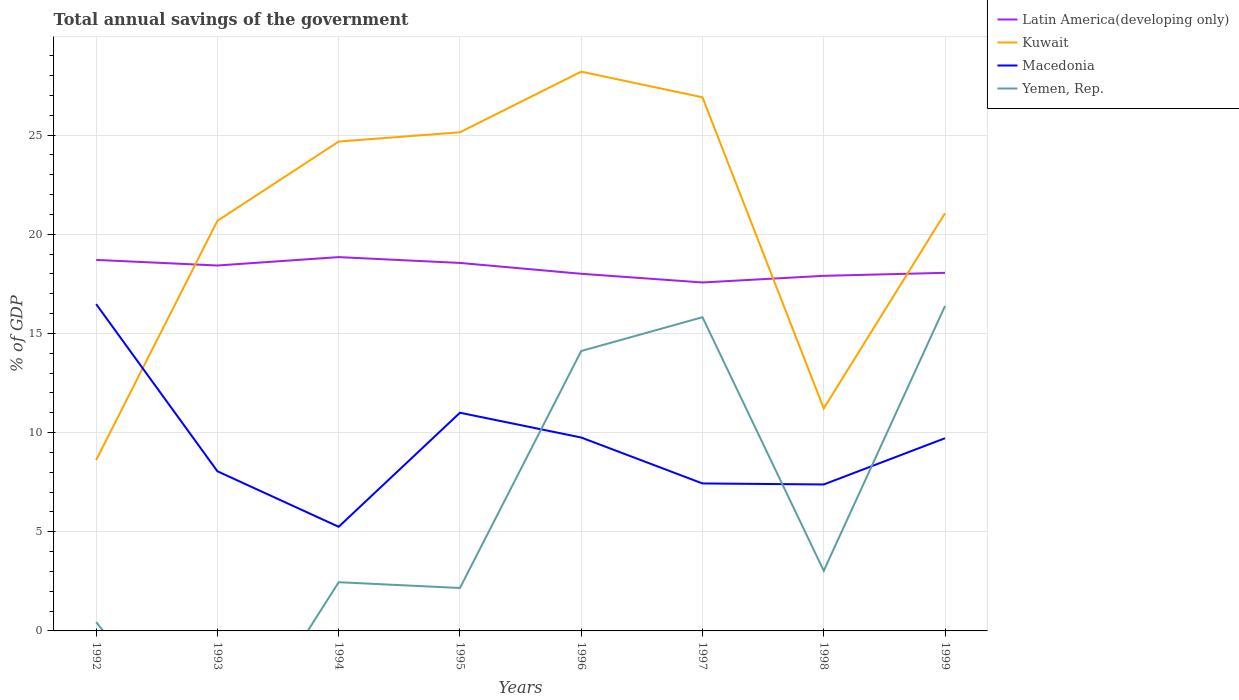Across all years, what is the maximum total annual savings of the government in Macedonia?
Offer a terse response. 5.25. What is the total total annual savings of the government in Kuwait in the graph?
Ensure brevity in your answer.  5.85. What is the difference between the highest and the second highest total annual savings of the government in Macedonia?
Give a very brief answer. 11.23. What is the difference between two consecutive major ticks on the Y-axis?
Offer a very short reply. 5. Does the graph contain any zero values?
Offer a terse response. Yes. How many legend labels are there?
Provide a short and direct response. 4. What is the title of the graph?
Provide a succinct answer. Total annual savings of the government. Does "Central African Republic" appear as one of the legend labels in the graph?
Give a very brief answer. No. What is the label or title of the X-axis?
Your answer should be very brief. Years. What is the label or title of the Y-axis?
Offer a very short reply. % of GDP. What is the % of GDP of Latin America(developing only) in 1992?
Ensure brevity in your answer.  18.71. What is the % of GDP in Kuwait in 1992?
Ensure brevity in your answer.  8.62. What is the % of GDP in Macedonia in 1992?
Offer a terse response. 16.48. What is the % of GDP of Yemen, Rep. in 1992?
Offer a very short reply. 0.45. What is the % of GDP of Latin America(developing only) in 1993?
Offer a terse response. 18.42. What is the % of GDP in Kuwait in 1993?
Provide a succinct answer. 20.68. What is the % of GDP of Macedonia in 1993?
Offer a very short reply. 8.05. What is the % of GDP of Yemen, Rep. in 1993?
Provide a succinct answer. 0. What is the % of GDP of Latin America(developing only) in 1994?
Ensure brevity in your answer.  18.85. What is the % of GDP in Kuwait in 1994?
Your answer should be compact. 24.67. What is the % of GDP in Macedonia in 1994?
Make the answer very short. 5.25. What is the % of GDP of Yemen, Rep. in 1994?
Your response must be concise. 2.46. What is the % of GDP in Latin America(developing only) in 1995?
Your response must be concise. 18.55. What is the % of GDP in Kuwait in 1995?
Make the answer very short. 25.14. What is the % of GDP in Macedonia in 1995?
Offer a terse response. 11. What is the % of GDP in Yemen, Rep. in 1995?
Keep it short and to the point. 2.16. What is the % of GDP of Latin America(developing only) in 1996?
Offer a very short reply. 18.01. What is the % of GDP of Kuwait in 1996?
Give a very brief answer. 28.2. What is the % of GDP in Macedonia in 1996?
Ensure brevity in your answer.  9.75. What is the % of GDP in Yemen, Rep. in 1996?
Keep it short and to the point. 14.11. What is the % of GDP in Latin America(developing only) in 1997?
Give a very brief answer. 17.57. What is the % of GDP in Kuwait in 1997?
Provide a short and direct response. 26.9. What is the % of GDP in Macedonia in 1997?
Provide a succinct answer. 7.44. What is the % of GDP of Yemen, Rep. in 1997?
Offer a terse response. 15.82. What is the % of GDP in Latin America(developing only) in 1998?
Offer a terse response. 17.9. What is the % of GDP of Kuwait in 1998?
Your answer should be very brief. 11.22. What is the % of GDP in Macedonia in 1998?
Keep it short and to the point. 7.38. What is the % of GDP of Yemen, Rep. in 1998?
Keep it short and to the point. 3.03. What is the % of GDP of Latin America(developing only) in 1999?
Offer a very short reply. 18.06. What is the % of GDP of Kuwait in 1999?
Make the answer very short. 21.06. What is the % of GDP of Macedonia in 1999?
Your response must be concise. 9.72. What is the % of GDP of Yemen, Rep. in 1999?
Provide a short and direct response. 16.38. Across all years, what is the maximum % of GDP in Latin America(developing only)?
Provide a succinct answer. 18.85. Across all years, what is the maximum % of GDP in Kuwait?
Your response must be concise. 28.2. Across all years, what is the maximum % of GDP in Macedonia?
Keep it short and to the point. 16.48. Across all years, what is the maximum % of GDP of Yemen, Rep.?
Provide a short and direct response. 16.38. Across all years, what is the minimum % of GDP of Latin America(developing only)?
Ensure brevity in your answer.  17.57. Across all years, what is the minimum % of GDP of Kuwait?
Keep it short and to the point. 8.62. Across all years, what is the minimum % of GDP in Macedonia?
Provide a succinct answer. 5.25. What is the total % of GDP of Latin America(developing only) in the graph?
Make the answer very short. 146.07. What is the total % of GDP in Kuwait in the graph?
Offer a very short reply. 166.49. What is the total % of GDP of Macedonia in the graph?
Offer a terse response. 75.07. What is the total % of GDP of Yemen, Rep. in the graph?
Offer a terse response. 54.41. What is the difference between the % of GDP of Latin America(developing only) in 1992 and that in 1993?
Offer a very short reply. 0.28. What is the difference between the % of GDP in Kuwait in 1992 and that in 1993?
Make the answer very short. -12.06. What is the difference between the % of GDP in Macedonia in 1992 and that in 1993?
Your answer should be very brief. 8.43. What is the difference between the % of GDP of Latin America(developing only) in 1992 and that in 1994?
Offer a terse response. -0.14. What is the difference between the % of GDP in Kuwait in 1992 and that in 1994?
Provide a succinct answer. -16.06. What is the difference between the % of GDP in Macedonia in 1992 and that in 1994?
Give a very brief answer. 11.23. What is the difference between the % of GDP in Yemen, Rep. in 1992 and that in 1994?
Your answer should be compact. -2.01. What is the difference between the % of GDP of Latin America(developing only) in 1992 and that in 1995?
Your response must be concise. 0.15. What is the difference between the % of GDP in Kuwait in 1992 and that in 1995?
Ensure brevity in your answer.  -16.53. What is the difference between the % of GDP in Macedonia in 1992 and that in 1995?
Keep it short and to the point. 5.48. What is the difference between the % of GDP in Yemen, Rep. in 1992 and that in 1995?
Your response must be concise. -1.72. What is the difference between the % of GDP in Latin America(developing only) in 1992 and that in 1996?
Keep it short and to the point. 0.7. What is the difference between the % of GDP in Kuwait in 1992 and that in 1996?
Keep it short and to the point. -19.58. What is the difference between the % of GDP in Macedonia in 1992 and that in 1996?
Your answer should be very brief. 6.73. What is the difference between the % of GDP of Yemen, Rep. in 1992 and that in 1996?
Ensure brevity in your answer.  -13.67. What is the difference between the % of GDP in Latin America(developing only) in 1992 and that in 1997?
Your answer should be compact. 1.14. What is the difference between the % of GDP in Kuwait in 1992 and that in 1997?
Offer a terse response. -18.29. What is the difference between the % of GDP of Macedonia in 1992 and that in 1997?
Provide a short and direct response. 9.04. What is the difference between the % of GDP in Yemen, Rep. in 1992 and that in 1997?
Provide a succinct answer. -15.37. What is the difference between the % of GDP of Latin America(developing only) in 1992 and that in 1998?
Your answer should be very brief. 0.8. What is the difference between the % of GDP in Kuwait in 1992 and that in 1998?
Your response must be concise. -2.6. What is the difference between the % of GDP of Macedonia in 1992 and that in 1998?
Keep it short and to the point. 9.09. What is the difference between the % of GDP of Yemen, Rep. in 1992 and that in 1998?
Make the answer very short. -2.58. What is the difference between the % of GDP in Latin America(developing only) in 1992 and that in 1999?
Offer a very short reply. 0.65. What is the difference between the % of GDP in Kuwait in 1992 and that in 1999?
Make the answer very short. -12.44. What is the difference between the % of GDP in Macedonia in 1992 and that in 1999?
Your response must be concise. 6.76. What is the difference between the % of GDP of Yemen, Rep. in 1992 and that in 1999?
Keep it short and to the point. -15.93. What is the difference between the % of GDP of Latin America(developing only) in 1993 and that in 1994?
Give a very brief answer. -0.42. What is the difference between the % of GDP of Kuwait in 1993 and that in 1994?
Make the answer very short. -4. What is the difference between the % of GDP in Macedonia in 1993 and that in 1994?
Provide a succinct answer. 2.8. What is the difference between the % of GDP in Latin America(developing only) in 1993 and that in 1995?
Provide a short and direct response. -0.13. What is the difference between the % of GDP in Kuwait in 1993 and that in 1995?
Your response must be concise. -4.46. What is the difference between the % of GDP in Macedonia in 1993 and that in 1995?
Provide a short and direct response. -2.95. What is the difference between the % of GDP in Latin America(developing only) in 1993 and that in 1996?
Keep it short and to the point. 0.42. What is the difference between the % of GDP of Kuwait in 1993 and that in 1996?
Provide a short and direct response. -7.52. What is the difference between the % of GDP in Macedonia in 1993 and that in 1996?
Your answer should be very brief. -1.7. What is the difference between the % of GDP in Latin America(developing only) in 1993 and that in 1997?
Provide a succinct answer. 0.86. What is the difference between the % of GDP in Kuwait in 1993 and that in 1997?
Provide a succinct answer. -6.23. What is the difference between the % of GDP in Macedonia in 1993 and that in 1997?
Your answer should be compact. 0.61. What is the difference between the % of GDP of Latin America(developing only) in 1993 and that in 1998?
Provide a short and direct response. 0.52. What is the difference between the % of GDP in Kuwait in 1993 and that in 1998?
Your answer should be compact. 9.46. What is the difference between the % of GDP of Macedonia in 1993 and that in 1998?
Keep it short and to the point. 0.67. What is the difference between the % of GDP in Latin America(developing only) in 1993 and that in 1999?
Keep it short and to the point. 0.37. What is the difference between the % of GDP of Kuwait in 1993 and that in 1999?
Make the answer very short. -0.38. What is the difference between the % of GDP in Macedonia in 1993 and that in 1999?
Offer a very short reply. -1.67. What is the difference between the % of GDP of Latin America(developing only) in 1994 and that in 1995?
Offer a very short reply. 0.29. What is the difference between the % of GDP in Kuwait in 1994 and that in 1995?
Keep it short and to the point. -0.47. What is the difference between the % of GDP in Macedonia in 1994 and that in 1995?
Keep it short and to the point. -5.75. What is the difference between the % of GDP of Yemen, Rep. in 1994 and that in 1995?
Ensure brevity in your answer.  0.29. What is the difference between the % of GDP of Latin America(developing only) in 1994 and that in 1996?
Your answer should be compact. 0.84. What is the difference between the % of GDP of Kuwait in 1994 and that in 1996?
Make the answer very short. -3.52. What is the difference between the % of GDP in Macedonia in 1994 and that in 1996?
Offer a terse response. -4.5. What is the difference between the % of GDP in Yemen, Rep. in 1994 and that in 1996?
Your answer should be very brief. -11.66. What is the difference between the % of GDP in Latin America(developing only) in 1994 and that in 1997?
Your response must be concise. 1.28. What is the difference between the % of GDP of Kuwait in 1994 and that in 1997?
Your response must be concise. -2.23. What is the difference between the % of GDP in Macedonia in 1994 and that in 1997?
Keep it short and to the point. -2.19. What is the difference between the % of GDP in Yemen, Rep. in 1994 and that in 1997?
Provide a succinct answer. -13.36. What is the difference between the % of GDP in Latin America(developing only) in 1994 and that in 1998?
Offer a terse response. 0.94. What is the difference between the % of GDP of Kuwait in 1994 and that in 1998?
Your answer should be very brief. 13.46. What is the difference between the % of GDP of Macedonia in 1994 and that in 1998?
Provide a succinct answer. -2.13. What is the difference between the % of GDP in Yemen, Rep. in 1994 and that in 1998?
Your answer should be compact. -0.58. What is the difference between the % of GDP of Latin America(developing only) in 1994 and that in 1999?
Provide a short and direct response. 0.79. What is the difference between the % of GDP of Kuwait in 1994 and that in 1999?
Give a very brief answer. 3.61. What is the difference between the % of GDP in Macedonia in 1994 and that in 1999?
Keep it short and to the point. -4.47. What is the difference between the % of GDP in Yemen, Rep. in 1994 and that in 1999?
Provide a succinct answer. -13.93. What is the difference between the % of GDP of Latin America(developing only) in 1995 and that in 1996?
Your response must be concise. 0.55. What is the difference between the % of GDP of Kuwait in 1995 and that in 1996?
Keep it short and to the point. -3.06. What is the difference between the % of GDP in Macedonia in 1995 and that in 1996?
Make the answer very short. 1.25. What is the difference between the % of GDP in Yemen, Rep. in 1995 and that in 1996?
Give a very brief answer. -11.95. What is the difference between the % of GDP of Latin America(developing only) in 1995 and that in 1997?
Provide a succinct answer. 0.98. What is the difference between the % of GDP in Kuwait in 1995 and that in 1997?
Give a very brief answer. -1.76. What is the difference between the % of GDP of Macedonia in 1995 and that in 1997?
Keep it short and to the point. 3.57. What is the difference between the % of GDP of Yemen, Rep. in 1995 and that in 1997?
Give a very brief answer. -13.65. What is the difference between the % of GDP of Latin America(developing only) in 1995 and that in 1998?
Ensure brevity in your answer.  0.65. What is the difference between the % of GDP in Kuwait in 1995 and that in 1998?
Your answer should be compact. 13.92. What is the difference between the % of GDP in Macedonia in 1995 and that in 1998?
Provide a short and direct response. 3.62. What is the difference between the % of GDP of Yemen, Rep. in 1995 and that in 1998?
Keep it short and to the point. -0.87. What is the difference between the % of GDP in Latin America(developing only) in 1995 and that in 1999?
Offer a terse response. 0.5. What is the difference between the % of GDP of Kuwait in 1995 and that in 1999?
Give a very brief answer. 4.08. What is the difference between the % of GDP of Macedonia in 1995 and that in 1999?
Provide a succinct answer. 1.28. What is the difference between the % of GDP in Yemen, Rep. in 1995 and that in 1999?
Provide a succinct answer. -14.22. What is the difference between the % of GDP in Latin America(developing only) in 1996 and that in 1997?
Provide a short and direct response. 0.44. What is the difference between the % of GDP of Kuwait in 1996 and that in 1997?
Offer a terse response. 1.29. What is the difference between the % of GDP of Macedonia in 1996 and that in 1997?
Keep it short and to the point. 2.32. What is the difference between the % of GDP in Yemen, Rep. in 1996 and that in 1997?
Provide a short and direct response. -1.7. What is the difference between the % of GDP in Latin America(developing only) in 1996 and that in 1998?
Make the answer very short. 0.1. What is the difference between the % of GDP of Kuwait in 1996 and that in 1998?
Offer a very short reply. 16.98. What is the difference between the % of GDP of Macedonia in 1996 and that in 1998?
Your response must be concise. 2.37. What is the difference between the % of GDP of Yemen, Rep. in 1996 and that in 1998?
Your answer should be compact. 11.08. What is the difference between the % of GDP in Latin America(developing only) in 1996 and that in 1999?
Offer a very short reply. -0.05. What is the difference between the % of GDP in Kuwait in 1996 and that in 1999?
Offer a terse response. 7.14. What is the difference between the % of GDP in Macedonia in 1996 and that in 1999?
Your answer should be compact. 0.04. What is the difference between the % of GDP in Yemen, Rep. in 1996 and that in 1999?
Offer a very short reply. -2.27. What is the difference between the % of GDP in Latin America(developing only) in 1997 and that in 1998?
Provide a succinct answer. -0.33. What is the difference between the % of GDP of Kuwait in 1997 and that in 1998?
Keep it short and to the point. 15.69. What is the difference between the % of GDP of Macedonia in 1997 and that in 1998?
Keep it short and to the point. 0.05. What is the difference between the % of GDP in Yemen, Rep. in 1997 and that in 1998?
Offer a very short reply. 12.79. What is the difference between the % of GDP in Latin America(developing only) in 1997 and that in 1999?
Your response must be concise. -0.49. What is the difference between the % of GDP in Kuwait in 1997 and that in 1999?
Your answer should be compact. 5.84. What is the difference between the % of GDP in Macedonia in 1997 and that in 1999?
Your answer should be compact. -2.28. What is the difference between the % of GDP in Yemen, Rep. in 1997 and that in 1999?
Your answer should be compact. -0.56. What is the difference between the % of GDP in Latin America(developing only) in 1998 and that in 1999?
Ensure brevity in your answer.  -0.15. What is the difference between the % of GDP in Kuwait in 1998 and that in 1999?
Ensure brevity in your answer.  -9.84. What is the difference between the % of GDP of Macedonia in 1998 and that in 1999?
Give a very brief answer. -2.33. What is the difference between the % of GDP of Yemen, Rep. in 1998 and that in 1999?
Offer a terse response. -13.35. What is the difference between the % of GDP in Latin America(developing only) in 1992 and the % of GDP in Kuwait in 1993?
Provide a short and direct response. -1.97. What is the difference between the % of GDP in Latin America(developing only) in 1992 and the % of GDP in Macedonia in 1993?
Your answer should be very brief. 10.66. What is the difference between the % of GDP in Kuwait in 1992 and the % of GDP in Macedonia in 1993?
Provide a short and direct response. 0.57. What is the difference between the % of GDP of Latin America(developing only) in 1992 and the % of GDP of Kuwait in 1994?
Provide a succinct answer. -5.97. What is the difference between the % of GDP in Latin America(developing only) in 1992 and the % of GDP in Macedonia in 1994?
Your answer should be compact. 13.46. What is the difference between the % of GDP of Latin America(developing only) in 1992 and the % of GDP of Yemen, Rep. in 1994?
Your answer should be very brief. 16.25. What is the difference between the % of GDP in Kuwait in 1992 and the % of GDP in Macedonia in 1994?
Your answer should be very brief. 3.37. What is the difference between the % of GDP in Kuwait in 1992 and the % of GDP in Yemen, Rep. in 1994?
Offer a very short reply. 6.16. What is the difference between the % of GDP in Macedonia in 1992 and the % of GDP in Yemen, Rep. in 1994?
Ensure brevity in your answer.  14.02. What is the difference between the % of GDP of Latin America(developing only) in 1992 and the % of GDP of Kuwait in 1995?
Ensure brevity in your answer.  -6.44. What is the difference between the % of GDP in Latin America(developing only) in 1992 and the % of GDP in Macedonia in 1995?
Offer a very short reply. 7.71. What is the difference between the % of GDP of Latin America(developing only) in 1992 and the % of GDP of Yemen, Rep. in 1995?
Make the answer very short. 16.54. What is the difference between the % of GDP in Kuwait in 1992 and the % of GDP in Macedonia in 1995?
Make the answer very short. -2.39. What is the difference between the % of GDP of Kuwait in 1992 and the % of GDP of Yemen, Rep. in 1995?
Give a very brief answer. 6.45. What is the difference between the % of GDP in Macedonia in 1992 and the % of GDP in Yemen, Rep. in 1995?
Offer a very short reply. 14.31. What is the difference between the % of GDP of Latin America(developing only) in 1992 and the % of GDP of Kuwait in 1996?
Your response must be concise. -9.49. What is the difference between the % of GDP of Latin America(developing only) in 1992 and the % of GDP of Macedonia in 1996?
Your answer should be very brief. 8.96. What is the difference between the % of GDP in Latin America(developing only) in 1992 and the % of GDP in Yemen, Rep. in 1996?
Keep it short and to the point. 4.59. What is the difference between the % of GDP in Kuwait in 1992 and the % of GDP in Macedonia in 1996?
Offer a terse response. -1.14. What is the difference between the % of GDP in Kuwait in 1992 and the % of GDP in Yemen, Rep. in 1996?
Your answer should be very brief. -5.5. What is the difference between the % of GDP in Macedonia in 1992 and the % of GDP in Yemen, Rep. in 1996?
Your answer should be compact. 2.37. What is the difference between the % of GDP of Latin America(developing only) in 1992 and the % of GDP of Kuwait in 1997?
Your answer should be very brief. -8.2. What is the difference between the % of GDP in Latin America(developing only) in 1992 and the % of GDP in Macedonia in 1997?
Offer a very short reply. 11.27. What is the difference between the % of GDP in Latin America(developing only) in 1992 and the % of GDP in Yemen, Rep. in 1997?
Make the answer very short. 2.89. What is the difference between the % of GDP of Kuwait in 1992 and the % of GDP of Macedonia in 1997?
Offer a terse response. 1.18. What is the difference between the % of GDP of Kuwait in 1992 and the % of GDP of Yemen, Rep. in 1997?
Ensure brevity in your answer.  -7.2. What is the difference between the % of GDP of Macedonia in 1992 and the % of GDP of Yemen, Rep. in 1997?
Your answer should be very brief. 0.66. What is the difference between the % of GDP of Latin America(developing only) in 1992 and the % of GDP of Kuwait in 1998?
Make the answer very short. 7.49. What is the difference between the % of GDP in Latin America(developing only) in 1992 and the % of GDP in Macedonia in 1998?
Your answer should be compact. 11.32. What is the difference between the % of GDP of Latin America(developing only) in 1992 and the % of GDP of Yemen, Rep. in 1998?
Give a very brief answer. 15.68. What is the difference between the % of GDP of Kuwait in 1992 and the % of GDP of Macedonia in 1998?
Provide a succinct answer. 1.23. What is the difference between the % of GDP in Kuwait in 1992 and the % of GDP in Yemen, Rep. in 1998?
Ensure brevity in your answer.  5.58. What is the difference between the % of GDP in Macedonia in 1992 and the % of GDP in Yemen, Rep. in 1998?
Make the answer very short. 13.45. What is the difference between the % of GDP of Latin America(developing only) in 1992 and the % of GDP of Kuwait in 1999?
Your answer should be compact. -2.35. What is the difference between the % of GDP of Latin America(developing only) in 1992 and the % of GDP of Macedonia in 1999?
Keep it short and to the point. 8.99. What is the difference between the % of GDP in Latin America(developing only) in 1992 and the % of GDP in Yemen, Rep. in 1999?
Keep it short and to the point. 2.33. What is the difference between the % of GDP in Kuwait in 1992 and the % of GDP in Macedonia in 1999?
Give a very brief answer. -1.1. What is the difference between the % of GDP in Kuwait in 1992 and the % of GDP in Yemen, Rep. in 1999?
Offer a terse response. -7.77. What is the difference between the % of GDP in Macedonia in 1992 and the % of GDP in Yemen, Rep. in 1999?
Ensure brevity in your answer.  0.1. What is the difference between the % of GDP in Latin America(developing only) in 1993 and the % of GDP in Kuwait in 1994?
Offer a very short reply. -6.25. What is the difference between the % of GDP of Latin America(developing only) in 1993 and the % of GDP of Macedonia in 1994?
Provide a short and direct response. 13.17. What is the difference between the % of GDP in Latin America(developing only) in 1993 and the % of GDP in Yemen, Rep. in 1994?
Your response must be concise. 15.97. What is the difference between the % of GDP of Kuwait in 1993 and the % of GDP of Macedonia in 1994?
Your answer should be very brief. 15.43. What is the difference between the % of GDP in Kuwait in 1993 and the % of GDP in Yemen, Rep. in 1994?
Provide a short and direct response. 18.22. What is the difference between the % of GDP in Macedonia in 1993 and the % of GDP in Yemen, Rep. in 1994?
Give a very brief answer. 5.59. What is the difference between the % of GDP of Latin America(developing only) in 1993 and the % of GDP of Kuwait in 1995?
Keep it short and to the point. -6.72. What is the difference between the % of GDP of Latin America(developing only) in 1993 and the % of GDP of Macedonia in 1995?
Make the answer very short. 7.42. What is the difference between the % of GDP in Latin America(developing only) in 1993 and the % of GDP in Yemen, Rep. in 1995?
Offer a terse response. 16.26. What is the difference between the % of GDP of Kuwait in 1993 and the % of GDP of Macedonia in 1995?
Give a very brief answer. 9.68. What is the difference between the % of GDP of Kuwait in 1993 and the % of GDP of Yemen, Rep. in 1995?
Offer a very short reply. 18.51. What is the difference between the % of GDP in Macedonia in 1993 and the % of GDP in Yemen, Rep. in 1995?
Offer a very short reply. 5.88. What is the difference between the % of GDP of Latin America(developing only) in 1993 and the % of GDP of Kuwait in 1996?
Your response must be concise. -9.77. What is the difference between the % of GDP in Latin America(developing only) in 1993 and the % of GDP in Macedonia in 1996?
Offer a terse response. 8.67. What is the difference between the % of GDP in Latin America(developing only) in 1993 and the % of GDP in Yemen, Rep. in 1996?
Ensure brevity in your answer.  4.31. What is the difference between the % of GDP of Kuwait in 1993 and the % of GDP of Macedonia in 1996?
Give a very brief answer. 10.93. What is the difference between the % of GDP in Kuwait in 1993 and the % of GDP in Yemen, Rep. in 1996?
Provide a succinct answer. 6.56. What is the difference between the % of GDP of Macedonia in 1993 and the % of GDP of Yemen, Rep. in 1996?
Your answer should be very brief. -6.06. What is the difference between the % of GDP of Latin America(developing only) in 1993 and the % of GDP of Kuwait in 1997?
Ensure brevity in your answer.  -8.48. What is the difference between the % of GDP in Latin America(developing only) in 1993 and the % of GDP in Macedonia in 1997?
Keep it short and to the point. 10.99. What is the difference between the % of GDP in Latin America(developing only) in 1993 and the % of GDP in Yemen, Rep. in 1997?
Your answer should be compact. 2.61. What is the difference between the % of GDP of Kuwait in 1993 and the % of GDP of Macedonia in 1997?
Your answer should be compact. 13.24. What is the difference between the % of GDP of Kuwait in 1993 and the % of GDP of Yemen, Rep. in 1997?
Offer a terse response. 4.86. What is the difference between the % of GDP in Macedonia in 1993 and the % of GDP in Yemen, Rep. in 1997?
Ensure brevity in your answer.  -7.77. What is the difference between the % of GDP in Latin America(developing only) in 1993 and the % of GDP in Kuwait in 1998?
Your answer should be compact. 7.21. What is the difference between the % of GDP in Latin America(developing only) in 1993 and the % of GDP in Macedonia in 1998?
Ensure brevity in your answer.  11.04. What is the difference between the % of GDP of Latin America(developing only) in 1993 and the % of GDP of Yemen, Rep. in 1998?
Your answer should be very brief. 15.39. What is the difference between the % of GDP of Kuwait in 1993 and the % of GDP of Macedonia in 1998?
Keep it short and to the point. 13.29. What is the difference between the % of GDP of Kuwait in 1993 and the % of GDP of Yemen, Rep. in 1998?
Provide a succinct answer. 17.65. What is the difference between the % of GDP of Macedonia in 1993 and the % of GDP of Yemen, Rep. in 1998?
Give a very brief answer. 5.02. What is the difference between the % of GDP in Latin America(developing only) in 1993 and the % of GDP in Kuwait in 1999?
Your answer should be compact. -2.64. What is the difference between the % of GDP in Latin America(developing only) in 1993 and the % of GDP in Macedonia in 1999?
Offer a terse response. 8.71. What is the difference between the % of GDP in Latin America(developing only) in 1993 and the % of GDP in Yemen, Rep. in 1999?
Ensure brevity in your answer.  2.04. What is the difference between the % of GDP in Kuwait in 1993 and the % of GDP in Macedonia in 1999?
Make the answer very short. 10.96. What is the difference between the % of GDP of Kuwait in 1993 and the % of GDP of Yemen, Rep. in 1999?
Make the answer very short. 4.3. What is the difference between the % of GDP in Macedonia in 1993 and the % of GDP in Yemen, Rep. in 1999?
Give a very brief answer. -8.33. What is the difference between the % of GDP of Latin America(developing only) in 1994 and the % of GDP of Kuwait in 1995?
Keep it short and to the point. -6.29. What is the difference between the % of GDP in Latin America(developing only) in 1994 and the % of GDP in Macedonia in 1995?
Provide a short and direct response. 7.85. What is the difference between the % of GDP of Latin America(developing only) in 1994 and the % of GDP of Yemen, Rep. in 1995?
Your answer should be very brief. 16.68. What is the difference between the % of GDP of Kuwait in 1994 and the % of GDP of Macedonia in 1995?
Make the answer very short. 13.67. What is the difference between the % of GDP in Kuwait in 1994 and the % of GDP in Yemen, Rep. in 1995?
Your response must be concise. 22.51. What is the difference between the % of GDP in Macedonia in 1994 and the % of GDP in Yemen, Rep. in 1995?
Make the answer very short. 3.09. What is the difference between the % of GDP in Latin America(developing only) in 1994 and the % of GDP in Kuwait in 1996?
Offer a very short reply. -9.35. What is the difference between the % of GDP of Latin America(developing only) in 1994 and the % of GDP of Macedonia in 1996?
Offer a terse response. 9.1. What is the difference between the % of GDP of Latin America(developing only) in 1994 and the % of GDP of Yemen, Rep. in 1996?
Offer a terse response. 4.73. What is the difference between the % of GDP in Kuwait in 1994 and the % of GDP in Macedonia in 1996?
Ensure brevity in your answer.  14.92. What is the difference between the % of GDP of Kuwait in 1994 and the % of GDP of Yemen, Rep. in 1996?
Your response must be concise. 10.56. What is the difference between the % of GDP of Macedonia in 1994 and the % of GDP of Yemen, Rep. in 1996?
Ensure brevity in your answer.  -8.86. What is the difference between the % of GDP in Latin America(developing only) in 1994 and the % of GDP in Kuwait in 1997?
Keep it short and to the point. -8.06. What is the difference between the % of GDP in Latin America(developing only) in 1994 and the % of GDP in Macedonia in 1997?
Make the answer very short. 11.41. What is the difference between the % of GDP of Latin America(developing only) in 1994 and the % of GDP of Yemen, Rep. in 1997?
Provide a short and direct response. 3.03. What is the difference between the % of GDP of Kuwait in 1994 and the % of GDP of Macedonia in 1997?
Your response must be concise. 17.24. What is the difference between the % of GDP in Kuwait in 1994 and the % of GDP in Yemen, Rep. in 1997?
Make the answer very short. 8.86. What is the difference between the % of GDP of Macedonia in 1994 and the % of GDP of Yemen, Rep. in 1997?
Your response must be concise. -10.57. What is the difference between the % of GDP of Latin America(developing only) in 1994 and the % of GDP of Kuwait in 1998?
Make the answer very short. 7.63. What is the difference between the % of GDP in Latin America(developing only) in 1994 and the % of GDP in Macedonia in 1998?
Give a very brief answer. 11.46. What is the difference between the % of GDP in Latin America(developing only) in 1994 and the % of GDP in Yemen, Rep. in 1998?
Provide a succinct answer. 15.82. What is the difference between the % of GDP in Kuwait in 1994 and the % of GDP in Macedonia in 1998?
Keep it short and to the point. 17.29. What is the difference between the % of GDP in Kuwait in 1994 and the % of GDP in Yemen, Rep. in 1998?
Offer a terse response. 21.64. What is the difference between the % of GDP in Macedonia in 1994 and the % of GDP in Yemen, Rep. in 1998?
Keep it short and to the point. 2.22. What is the difference between the % of GDP of Latin America(developing only) in 1994 and the % of GDP of Kuwait in 1999?
Keep it short and to the point. -2.21. What is the difference between the % of GDP of Latin America(developing only) in 1994 and the % of GDP of Macedonia in 1999?
Keep it short and to the point. 9.13. What is the difference between the % of GDP of Latin America(developing only) in 1994 and the % of GDP of Yemen, Rep. in 1999?
Offer a terse response. 2.47. What is the difference between the % of GDP in Kuwait in 1994 and the % of GDP in Macedonia in 1999?
Your response must be concise. 14.96. What is the difference between the % of GDP in Kuwait in 1994 and the % of GDP in Yemen, Rep. in 1999?
Make the answer very short. 8.29. What is the difference between the % of GDP of Macedonia in 1994 and the % of GDP of Yemen, Rep. in 1999?
Offer a very short reply. -11.13. What is the difference between the % of GDP of Latin America(developing only) in 1995 and the % of GDP of Kuwait in 1996?
Provide a succinct answer. -9.65. What is the difference between the % of GDP of Latin America(developing only) in 1995 and the % of GDP of Macedonia in 1996?
Your answer should be very brief. 8.8. What is the difference between the % of GDP of Latin America(developing only) in 1995 and the % of GDP of Yemen, Rep. in 1996?
Give a very brief answer. 4.44. What is the difference between the % of GDP in Kuwait in 1995 and the % of GDP in Macedonia in 1996?
Your answer should be very brief. 15.39. What is the difference between the % of GDP in Kuwait in 1995 and the % of GDP in Yemen, Rep. in 1996?
Offer a terse response. 11.03. What is the difference between the % of GDP of Macedonia in 1995 and the % of GDP of Yemen, Rep. in 1996?
Give a very brief answer. -3.11. What is the difference between the % of GDP of Latin America(developing only) in 1995 and the % of GDP of Kuwait in 1997?
Keep it short and to the point. -8.35. What is the difference between the % of GDP in Latin America(developing only) in 1995 and the % of GDP in Macedonia in 1997?
Offer a terse response. 11.12. What is the difference between the % of GDP in Latin America(developing only) in 1995 and the % of GDP in Yemen, Rep. in 1997?
Keep it short and to the point. 2.74. What is the difference between the % of GDP of Kuwait in 1995 and the % of GDP of Macedonia in 1997?
Offer a very short reply. 17.71. What is the difference between the % of GDP in Kuwait in 1995 and the % of GDP in Yemen, Rep. in 1997?
Your answer should be compact. 9.32. What is the difference between the % of GDP of Macedonia in 1995 and the % of GDP of Yemen, Rep. in 1997?
Give a very brief answer. -4.82. What is the difference between the % of GDP of Latin America(developing only) in 1995 and the % of GDP of Kuwait in 1998?
Provide a short and direct response. 7.34. What is the difference between the % of GDP of Latin America(developing only) in 1995 and the % of GDP of Macedonia in 1998?
Give a very brief answer. 11.17. What is the difference between the % of GDP in Latin America(developing only) in 1995 and the % of GDP in Yemen, Rep. in 1998?
Your answer should be very brief. 15.52. What is the difference between the % of GDP of Kuwait in 1995 and the % of GDP of Macedonia in 1998?
Your answer should be very brief. 17.76. What is the difference between the % of GDP of Kuwait in 1995 and the % of GDP of Yemen, Rep. in 1998?
Give a very brief answer. 22.11. What is the difference between the % of GDP in Macedonia in 1995 and the % of GDP in Yemen, Rep. in 1998?
Your response must be concise. 7.97. What is the difference between the % of GDP of Latin America(developing only) in 1995 and the % of GDP of Kuwait in 1999?
Provide a short and direct response. -2.51. What is the difference between the % of GDP of Latin America(developing only) in 1995 and the % of GDP of Macedonia in 1999?
Provide a succinct answer. 8.84. What is the difference between the % of GDP of Latin America(developing only) in 1995 and the % of GDP of Yemen, Rep. in 1999?
Ensure brevity in your answer.  2.17. What is the difference between the % of GDP of Kuwait in 1995 and the % of GDP of Macedonia in 1999?
Your answer should be compact. 15.43. What is the difference between the % of GDP in Kuwait in 1995 and the % of GDP in Yemen, Rep. in 1999?
Ensure brevity in your answer.  8.76. What is the difference between the % of GDP in Macedonia in 1995 and the % of GDP in Yemen, Rep. in 1999?
Provide a succinct answer. -5.38. What is the difference between the % of GDP of Latin America(developing only) in 1996 and the % of GDP of Kuwait in 1997?
Make the answer very short. -8.9. What is the difference between the % of GDP of Latin America(developing only) in 1996 and the % of GDP of Macedonia in 1997?
Keep it short and to the point. 10.57. What is the difference between the % of GDP in Latin America(developing only) in 1996 and the % of GDP in Yemen, Rep. in 1997?
Offer a very short reply. 2.19. What is the difference between the % of GDP of Kuwait in 1996 and the % of GDP of Macedonia in 1997?
Your answer should be compact. 20.76. What is the difference between the % of GDP of Kuwait in 1996 and the % of GDP of Yemen, Rep. in 1997?
Provide a succinct answer. 12.38. What is the difference between the % of GDP in Macedonia in 1996 and the % of GDP in Yemen, Rep. in 1997?
Give a very brief answer. -6.07. What is the difference between the % of GDP of Latin America(developing only) in 1996 and the % of GDP of Kuwait in 1998?
Give a very brief answer. 6.79. What is the difference between the % of GDP of Latin America(developing only) in 1996 and the % of GDP of Macedonia in 1998?
Your response must be concise. 10.62. What is the difference between the % of GDP of Latin America(developing only) in 1996 and the % of GDP of Yemen, Rep. in 1998?
Ensure brevity in your answer.  14.98. What is the difference between the % of GDP in Kuwait in 1996 and the % of GDP in Macedonia in 1998?
Provide a short and direct response. 20.82. What is the difference between the % of GDP of Kuwait in 1996 and the % of GDP of Yemen, Rep. in 1998?
Make the answer very short. 25.17. What is the difference between the % of GDP in Macedonia in 1996 and the % of GDP in Yemen, Rep. in 1998?
Provide a short and direct response. 6.72. What is the difference between the % of GDP in Latin America(developing only) in 1996 and the % of GDP in Kuwait in 1999?
Offer a terse response. -3.05. What is the difference between the % of GDP of Latin America(developing only) in 1996 and the % of GDP of Macedonia in 1999?
Provide a succinct answer. 8.29. What is the difference between the % of GDP in Latin America(developing only) in 1996 and the % of GDP in Yemen, Rep. in 1999?
Provide a succinct answer. 1.63. What is the difference between the % of GDP of Kuwait in 1996 and the % of GDP of Macedonia in 1999?
Make the answer very short. 18.48. What is the difference between the % of GDP in Kuwait in 1996 and the % of GDP in Yemen, Rep. in 1999?
Give a very brief answer. 11.82. What is the difference between the % of GDP in Macedonia in 1996 and the % of GDP in Yemen, Rep. in 1999?
Your response must be concise. -6.63. What is the difference between the % of GDP of Latin America(developing only) in 1997 and the % of GDP of Kuwait in 1998?
Offer a terse response. 6.35. What is the difference between the % of GDP of Latin America(developing only) in 1997 and the % of GDP of Macedonia in 1998?
Offer a very short reply. 10.19. What is the difference between the % of GDP of Latin America(developing only) in 1997 and the % of GDP of Yemen, Rep. in 1998?
Give a very brief answer. 14.54. What is the difference between the % of GDP in Kuwait in 1997 and the % of GDP in Macedonia in 1998?
Provide a short and direct response. 19.52. What is the difference between the % of GDP of Kuwait in 1997 and the % of GDP of Yemen, Rep. in 1998?
Ensure brevity in your answer.  23.87. What is the difference between the % of GDP of Macedonia in 1997 and the % of GDP of Yemen, Rep. in 1998?
Give a very brief answer. 4.4. What is the difference between the % of GDP of Latin America(developing only) in 1997 and the % of GDP of Kuwait in 1999?
Your response must be concise. -3.49. What is the difference between the % of GDP in Latin America(developing only) in 1997 and the % of GDP in Macedonia in 1999?
Your answer should be very brief. 7.85. What is the difference between the % of GDP of Latin America(developing only) in 1997 and the % of GDP of Yemen, Rep. in 1999?
Offer a very short reply. 1.19. What is the difference between the % of GDP of Kuwait in 1997 and the % of GDP of Macedonia in 1999?
Offer a very short reply. 17.19. What is the difference between the % of GDP of Kuwait in 1997 and the % of GDP of Yemen, Rep. in 1999?
Provide a short and direct response. 10.52. What is the difference between the % of GDP in Macedonia in 1997 and the % of GDP in Yemen, Rep. in 1999?
Your answer should be very brief. -8.95. What is the difference between the % of GDP of Latin America(developing only) in 1998 and the % of GDP of Kuwait in 1999?
Your answer should be compact. -3.16. What is the difference between the % of GDP of Latin America(developing only) in 1998 and the % of GDP of Macedonia in 1999?
Your answer should be compact. 8.19. What is the difference between the % of GDP of Latin America(developing only) in 1998 and the % of GDP of Yemen, Rep. in 1999?
Your answer should be compact. 1.52. What is the difference between the % of GDP of Kuwait in 1998 and the % of GDP of Macedonia in 1999?
Ensure brevity in your answer.  1.5. What is the difference between the % of GDP in Kuwait in 1998 and the % of GDP in Yemen, Rep. in 1999?
Make the answer very short. -5.16. What is the difference between the % of GDP of Macedonia in 1998 and the % of GDP of Yemen, Rep. in 1999?
Your answer should be very brief. -9. What is the average % of GDP of Latin America(developing only) per year?
Your answer should be compact. 18.26. What is the average % of GDP in Kuwait per year?
Provide a succinct answer. 20.81. What is the average % of GDP in Macedonia per year?
Provide a succinct answer. 9.38. What is the average % of GDP of Yemen, Rep. per year?
Offer a terse response. 6.8. In the year 1992, what is the difference between the % of GDP of Latin America(developing only) and % of GDP of Kuwait?
Provide a succinct answer. 10.09. In the year 1992, what is the difference between the % of GDP in Latin America(developing only) and % of GDP in Macedonia?
Keep it short and to the point. 2.23. In the year 1992, what is the difference between the % of GDP of Latin America(developing only) and % of GDP of Yemen, Rep.?
Your response must be concise. 18.26. In the year 1992, what is the difference between the % of GDP of Kuwait and % of GDP of Macedonia?
Your response must be concise. -7.86. In the year 1992, what is the difference between the % of GDP in Kuwait and % of GDP in Yemen, Rep.?
Your response must be concise. 8.17. In the year 1992, what is the difference between the % of GDP in Macedonia and % of GDP in Yemen, Rep.?
Offer a terse response. 16.03. In the year 1993, what is the difference between the % of GDP in Latin America(developing only) and % of GDP in Kuwait?
Your answer should be very brief. -2.25. In the year 1993, what is the difference between the % of GDP of Latin America(developing only) and % of GDP of Macedonia?
Offer a very short reply. 10.38. In the year 1993, what is the difference between the % of GDP of Kuwait and % of GDP of Macedonia?
Your answer should be very brief. 12.63. In the year 1994, what is the difference between the % of GDP in Latin America(developing only) and % of GDP in Kuwait?
Offer a terse response. -5.83. In the year 1994, what is the difference between the % of GDP in Latin America(developing only) and % of GDP in Macedonia?
Make the answer very short. 13.6. In the year 1994, what is the difference between the % of GDP of Latin America(developing only) and % of GDP of Yemen, Rep.?
Your answer should be very brief. 16.39. In the year 1994, what is the difference between the % of GDP of Kuwait and % of GDP of Macedonia?
Offer a terse response. 19.42. In the year 1994, what is the difference between the % of GDP of Kuwait and % of GDP of Yemen, Rep.?
Provide a short and direct response. 22.22. In the year 1994, what is the difference between the % of GDP of Macedonia and % of GDP of Yemen, Rep.?
Provide a short and direct response. 2.79. In the year 1995, what is the difference between the % of GDP in Latin America(developing only) and % of GDP in Kuwait?
Offer a terse response. -6.59. In the year 1995, what is the difference between the % of GDP of Latin America(developing only) and % of GDP of Macedonia?
Make the answer very short. 7.55. In the year 1995, what is the difference between the % of GDP in Latin America(developing only) and % of GDP in Yemen, Rep.?
Offer a terse response. 16.39. In the year 1995, what is the difference between the % of GDP in Kuwait and % of GDP in Macedonia?
Offer a very short reply. 14.14. In the year 1995, what is the difference between the % of GDP in Kuwait and % of GDP in Yemen, Rep.?
Your response must be concise. 22.98. In the year 1995, what is the difference between the % of GDP in Macedonia and % of GDP in Yemen, Rep.?
Your answer should be compact. 8.84. In the year 1996, what is the difference between the % of GDP of Latin America(developing only) and % of GDP of Kuwait?
Provide a succinct answer. -10.19. In the year 1996, what is the difference between the % of GDP of Latin America(developing only) and % of GDP of Macedonia?
Your answer should be compact. 8.26. In the year 1996, what is the difference between the % of GDP in Latin America(developing only) and % of GDP in Yemen, Rep.?
Offer a terse response. 3.89. In the year 1996, what is the difference between the % of GDP in Kuwait and % of GDP in Macedonia?
Provide a short and direct response. 18.45. In the year 1996, what is the difference between the % of GDP of Kuwait and % of GDP of Yemen, Rep.?
Your response must be concise. 14.09. In the year 1996, what is the difference between the % of GDP in Macedonia and % of GDP in Yemen, Rep.?
Provide a succinct answer. -4.36. In the year 1997, what is the difference between the % of GDP of Latin America(developing only) and % of GDP of Kuwait?
Keep it short and to the point. -9.34. In the year 1997, what is the difference between the % of GDP of Latin America(developing only) and % of GDP of Macedonia?
Keep it short and to the point. 10.13. In the year 1997, what is the difference between the % of GDP of Latin America(developing only) and % of GDP of Yemen, Rep.?
Make the answer very short. 1.75. In the year 1997, what is the difference between the % of GDP of Kuwait and % of GDP of Macedonia?
Give a very brief answer. 19.47. In the year 1997, what is the difference between the % of GDP in Kuwait and % of GDP in Yemen, Rep.?
Provide a short and direct response. 11.09. In the year 1997, what is the difference between the % of GDP of Macedonia and % of GDP of Yemen, Rep.?
Provide a succinct answer. -8.38. In the year 1998, what is the difference between the % of GDP of Latin America(developing only) and % of GDP of Kuwait?
Keep it short and to the point. 6.69. In the year 1998, what is the difference between the % of GDP in Latin America(developing only) and % of GDP in Macedonia?
Offer a terse response. 10.52. In the year 1998, what is the difference between the % of GDP in Latin America(developing only) and % of GDP in Yemen, Rep.?
Make the answer very short. 14.87. In the year 1998, what is the difference between the % of GDP of Kuwait and % of GDP of Macedonia?
Ensure brevity in your answer.  3.83. In the year 1998, what is the difference between the % of GDP in Kuwait and % of GDP in Yemen, Rep.?
Make the answer very short. 8.19. In the year 1998, what is the difference between the % of GDP in Macedonia and % of GDP in Yemen, Rep.?
Provide a succinct answer. 4.35. In the year 1999, what is the difference between the % of GDP of Latin America(developing only) and % of GDP of Kuwait?
Give a very brief answer. -3. In the year 1999, what is the difference between the % of GDP in Latin America(developing only) and % of GDP in Macedonia?
Your answer should be compact. 8.34. In the year 1999, what is the difference between the % of GDP of Latin America(developing only) and % of GDP of Yemen, Rep.?
Your answer should be compact. 1.67. In the year 1999, what is the difference between the % of GDP of Kuwait and % of GDP of Macedonia?
Your response must be concise. 11.34. In the year 1999, what is the difference between the % of GDP of Kuwait and % of GDP of Yemen, Rep.?
Your response must be concise. 4.68. In the year 1999, what is the difference between the % of GDP of Macedonia and % of GDP of Yemen, Rep.?
Offer a terse response. -6.66. What is the ratio of the % of GDP in Latin America(developing only) in 1992 to that in 1993?
Your answer should be compact. 1.02. What is the ratio of the % of GDP of Kuwait in 1992 to that in 1993?
Your answer should be compact. 0.42. What is the ratio of the % of GDP of Macedonia in 1992 to that in 1993?
Provide a short and direct response. 2.05. What is the ratio of the % of GDP in Latin America(developing only) in 1992 to that in 1994?
Keep it short and to the point. 0.99. What is the ratio of the % of GDP of Kuwait in 1992 to that in 1994?
Provide a short and direct response. 0.35. What is the ratio of the % of GDP in Macedonia in 1992 to that in 1994?
Keep it short and to the point. 3.14. What is the ratio of the % of GDP in Yemen, Rep. in 1992 to that in 1994?
Give a very brief answer. 0.18. What is the ratio of the % of GDP in Latin America(developing only) in 1992 to that in 1995?
Give a very brief answer. 1.01. What is the ratio of the % of GDP in Kuwait in 1992 to that in 1995?
Keep it short and to the point. 0.34. What is the ratio of the % of GDP of Macedonia in 1992 to that in 1995?
Provide a succinct answer. 1.5. What is the ratio of the % of GDP of Yemen, Rep. in 1992 to that in 1995?
Provide a short and direct response. 0.21. What is the ratio of the % of GDP in Latin America(developing only) in 1992 to that in 1996?
Provide a succinct answer. 1.04. What is the ratio of the % of GDP of Kuwait in 1992 to that in 1996?
Your response must be concise. 0.31. What is the ratio of the % of GDP in Macedonia in 1992 to that in 1996?
Keep it short and to the point. 1.69. What is the ratio of the % of GDP of Yemen, Rep. in 1992 to that in 1996?
Your answer should be very brief. 0.03. What is the ratio of the % of GDP in Latin America(developing only) in 1992 to that in 1997?
Make the answer very short. 1.06. What is the ratio of the % of GDP in Kuwait in 1992 to that in 1997?
Offer a terse response. 0.32. What is the ratio of the % of GDP in Macedonia in 1992 to that in 1997?
Ensure brevity in your answer.  2.22. What is the ratio of the % of GDP of Yemen, Rep. in 1992 to that in 1997?
Ensure brevity in your answer.  0.03. What is the ratio of the % of GDP of Latin America(developing only) in 1992 to that in 1998?
Provide a succinct answer. 1.04. What is the ratio of the % of GDP of Kuwait in 1992 to that in 1998?
Offer a terse response. 0.77. What is the ratio of the % of GDP in Macedonia in 1992 to that in 1998?
Provide a succinct answer. 2.23. What is the ratio of the % of GDP in Yemen, Rep. in 1992 to that in 1998?
Your response must be concise. 0.15. What is the ratio of the % of GDP of Latin America(developing only) in 1992 to that in 1999?
Offer a very short reply. 1.04. What is the ratio of the % of GDP in Kuwait in 1992 to that in 1999?
Keep it short and to the point. 0.41. What is the ratio of the % of GDP in Macedonia in 1992 to that in 1999?
Your answer should be compact. 1.7. What is the ratio of the % of GDP in Yemen, Rep. in 1992 to that in 1999?
Provide a short and direct response. 0.03. What is the ratio of the % of GDP of Latin America(developing only) in 1993 to that in 1994?
Offer a very short reply. 0.98. What is the ratio of the % of GDP of Kuwait in 1993 to that in 1994?
Make the answer very short. 0.84. What is the ratio of the % of GDP in Macedonia in 1993 to that in 1994?
Offer a terse response. 1.53. What is the ratio of the % of GDP in Latin America(developing only) in 1993 to that in 1995?
Make the answer very short. 0.99. What is the ratio of the % of GDP in Kuwait in 1993 to that in 1995?
Your answer should be compact. 0.82. What is the ratio of the % of GDP of Macedonia in 1993 to that in 1995?
Ensure brevity in your answer.  0.73. What is the ratio of the % of GDP in Latin America(developing only) in 1993 to that in 1996?
Ensure brevity in your answer.  1.02. What is the ratio of the % of GDP in Kuwait in 1993 to that in 1996?
Make the answer very short. 0.73. What is the ratio of the % of GDP of Macedonia in 1993 to that in 1996?
Offer a terse response. 0.83. What is the ratio of the % of GDP of Latin America(developing only) in 1993 to that in 1997?
Provide a succinct answer. 1.05. What is the ratio of the % of GDP of Kuwait in 1993 to that in 1997?
Provide a short and direct response. 0.77. What is the ratio of the % of GDP of Macedonia in 1993 to that in 1997?
Your answer should be very brief. 1.08. What is the ratio of the % of GDP in Latin America(developing only) in 1993 to that in 1998?
Offer a terse response. 1.03. What is the ratio of the % of GDP in Kuwait in 1993 to that in 1998?
Provide a short and direct response. 1.84. What is the ratio of the % of GDP in Macedonia in 1993 to that in 1998?
Offer a terse response. 1.09. What is the ratio of the % of GDP of Latin America(developing only) in 1993 to that in 1999?
Ensure brevity in your answer.  1.02. What is the ratio of the % of GDP in Kuwait in 1993 to that in 1999?
Offer a very short reply. 0.98. What is the ratio of the % of GDP in Macedonia in 1993 to that in 1999?
Your answer should be very brief. 0.83. What is the ratio of the % of GDP in Latin America(developing only) in 1994 to that in 1995?
Offer a terse response. 1.02. What is the ratio of the % of GDP in Kuwait in 1994 to that in 1995?
Give a very brief answer. 0.98. What is the ratio of the % of GDP of Macedonia in 1994 to that in 1995?
Provide a succinct answer. 0.48. What is the ratio of the % of GDP of Yemen, Rep. in 1994 to that in 1995?
Your answer should be very brief. 1.13. What is the ratio of the % of GDP in Latin America(developing only) in 1994 to that in 1996?
Offer a terse response. 1.05. What is the ratio of the % of GDP of Kuwait in 1994 to that in 1996?
Provide a short and direct response. 0.88. What is the ratio of the % of GDP of Macedonia in 1994 to that in 1996?
Make the answer very short. 0.54. What is the ratio of the % of GDP of Yemen, Rep. in 1994 to that in 1996?
Your answer should be very brief. 0.17. What is the ratio of the % of GDP in Latin America(developing only) in 1994 to that in 1997?
Your answer should be compact. 1.07. What is the ratio of the % of GDP in Kuwait in 1994 to that in 1997?
Ensure brevity in your answer.  0.92. What is the ratio of the % of GDP in Macedonia in 1994 to that in 1997?
Keep it short and to the point. 0.71. What is the ratio of the % of GDP of Yemen, Rep. in 1994 to that in 1997?
Your answer should be compact. 0.16. What is the ratio of the % of GDP in Latin America(developing only) in 1994 to that in 1998?
Provide a succinct answer. 1.05. What is the ratio of the % of GDP in Kuwait in 1994 to that in 1998?
Ensure brevity in your answer.  2.2. What is the ratio of the % of GDP in Macedonia in 1994 to that in 1998?
Your response must be concise. 0.71. What is the ratio of the % of GDP in Yemen, Rep. in 1994 to that in 1998?
Give a very brief answer. 0.81. What is the ratio of the % of GDP of Latin America(developing only) in 1994 to that in 1999?
Your answer should be very brief. 1.04. What is the ratio of the % of GDP of Kuwait in 1994 to that in 1999?
Give a very brief answer. 1.17. What is the ratio of the % of GDP of Macedonia in 1994 to that in 1999?
Make the answer very short. 0.54. What is the ratio of the % of GDP of Yemen, Rep. in 1994 to that in 1999?
Provide a short and direct response. 0.15. What is the ratio of the % of GDP of Latin America(developing only) in 1995 to that in 1996?
Make the answer very short. 1.03. What is the ratio of the % of GDP of Kuwait in 1995 to that in 1996?
Keep it short and to the point. 0.89. What is the ratio of the % of GDP in Macedonia in 1995 to that in 1996?
Your answer should be compact. 1.13. What is the ratio of the % of GDP in Yemen, Rep. in 1995 to that in 1996?
Make the answer very short. 0.15. What is the ratio of the % of GDP of Latin America(developing only) in 1995 to that in 1997?
Offer a terse response. 1.06. What is the ratio of the % of GDP of Kuwait in 1995 to that in 1997?
Your answer should be compact. 0.93. What is the ratio of the % of GDP in Macedonia in 1995 to that in 1997?
Your answer should be compact. 1.48. What is the ratio of the % of GDP of Yemen, Rep. in 1995 to that in 1997?
Your answer should be compact. 0.14. What is the ratio of the % of GDP of Latin America(developing only) in 1995 to that in 1998?
Provide a short and direct response. 1.04. What is the ratio of the % of GDP of Kuwait in 1995 to that in 1998?
Keep it short and to the point. 2.24. What is the ratio of the % of GDP of Macedonia in 1995 to that in 1998?
Your answer should be very brief. 1.49. What is the ratio of the % of GDP of Yemen, Rep. in 1995 to that in 1998?
Make the answer very short. 0.71. What is the ratio of the % of GDP in Latin America(developing only) in 1995 to that in 1999?
Your answer should be compact. 1.03. What is the ratio of the % of GDP in Kuwait in 1995 to that in 1999?
Offer a very short reply. 1.19. What is the ratio of the % of GDP of Macedonia in 1995 to that in 1999?
Provide a succinct answer. 1.13. What is the ratio of the % of GDP in Yemen, Rep. in 1995 to that in 1999?
Your response must be concise. 0.13. What is the ratio of the % of GDP in Latin America(developing only) in 1996 to that in 1997?
Your answer should be compact. 1.02. What is the ratio of the % of GDP of Kuwait in 1996 to that in 1997?
Offer a very short reply. 1.05. What is the ratio of the % of GDP in Macedonia in 1996 to that in 1997?
Your answer should be compact. 1.31. What is the ratio of the % of GDP of Yemen, Rep. in 1996 to that in 1997?
Ensure brevity in your answer.  0.89. What is the ratio of the % of GDP in Latin America(developing only) in 1996 to that in 1998?
Provide a succinct answer. 1.01. What is the ratio of the % of GDP of Kuwait in 1996 to that in 1998?
Ensure brevity in your answer.  2.51. What is the ratio of the % of GDP of Macedonia in 1996 to that in 1998?
Make the answer very short. 1.32. What is the ratio of the % of GDP in Yemen, Rep. in 1996 to that in 1998?
Provide a short and direct response. 4.66. What is the ratio of the % of GDP in Latin America(developing only) in 1996 to that in 1999?
Your answer should be very brief. 1. What is the ratio of the % of GDP of Kuwait in 1996 to that in 1999?
Your answer should be very brief. 1.34. What is the ratio of the % of GDP in Yemen, Rep. in 1996 to that in 1999?
Your response must be concise. 0.86. What is the ratio of the % of GDP in Latin America(developing only) in 1997 to that in 1998?
Ensure brevity in your answer.  0.98. What is the ratio of the % of GDP in Kuwait in 1997 to that in 1998?
Give a very brief answer. 2.4. What is the ratio of the % of GDP of Yemen, Rep. in 1997 to that in 1998?
Keep it short and to the point. 5.22. What is the ratio of the % of GDP in Latin America(developing only) in 1997 to that in 1999?
Keep it short and to the point. 0.97. What is the ratio of the % of GDP of Kuwait in 1997 to that in 1999?
Give a very brief answer. 1.28. What is the ratio of the % of GDP in Macedonia in 1997 to that in 1999?
Keep it short and to the point. 0.77. What is the ratio of the % of GDP of Yemen, Rep. in 1997 to that in 1999?
Offer a very short reply. 0.97. What is the ratio of the % of GDP of Kuwait in 1998 to that in 1999?
Give a very brief answer. 0.53. What is the ratio of the % of GDP of Macedonia in 1998 to that in 1999?
Provide a short and direct response. 0.76. What is the ratio of the % of GDP of Yemen, Rep. in 1998 to that in 1999?
Offer a very short reply. 0.19. What is the difference between the highest and the second highest % of GDP of Latin America(developing only)?
Provide a short and direct response. 0.14. What is the difference between the highest and the second highest % of GDP in Kuwait?
Provide a succinct answer. 1.29. What is the difference between the highest and the second highest % of GDP in Macedonia?
Make the answer very short. 5.48. What is the difference between the highest and the second highest % of GDP in Yemen, Rep.?
Your response must be concise. 0.56. What is the difference between the highest and the lowest % of GDP of Latin America(developing only)?
Offer a very short reply. 1.28. What is the difference between the highest and the lowest % of GDP of Kuwait?
Your answer should be compact. 19.58. What is the difference between the highest and the lowest % of GDP of Macedonia?
Provide a succinct answer. 11.23. What is the difference between the highest and the lowest % of GDP of Yemen, Rep.?
Your answer should be compact. 16.38. 